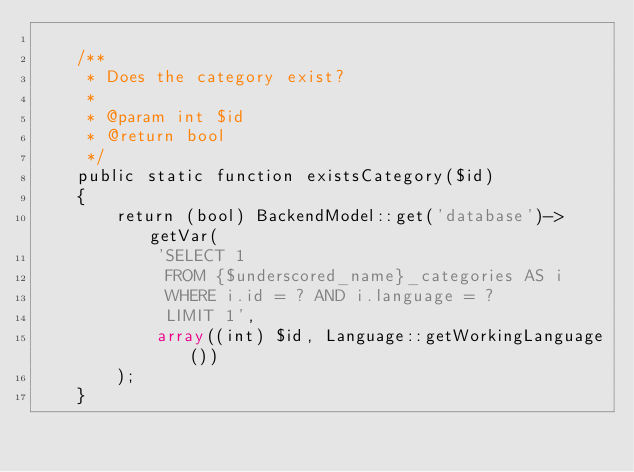<code> <loc_0><loc_0><loc_500><loc_500><_PHP_>
    /**
     * Does the category exist?
     *
     * @param int $id
     * @return bool
     */
    public static function existsCategory($id)
    {
        return (bool) BackendModel::get('database')->getVar(
            'SELECT 1
             FROM {$underscored_name}_categories AS i
             WHERE i.id = ? AND i.language = ?
             LIMIT 1',
            array((int) $id, Language::getWorkingLanguage())
        );
    }
</code> 